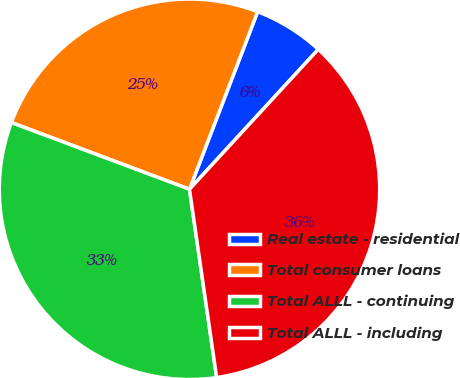Convert chart. <chart><loc_0><loc_0><loc_500><loc_500><pie_chart><fcel>Real estate - residential<fcel>Total consumer loans<fcel>Total ALLL - continuing<fcel>Total ALLL - including<nl><fcel>6.01%<fcel>25.13%<fcel>32.99%<fcel>35.88%<nl></chart> 